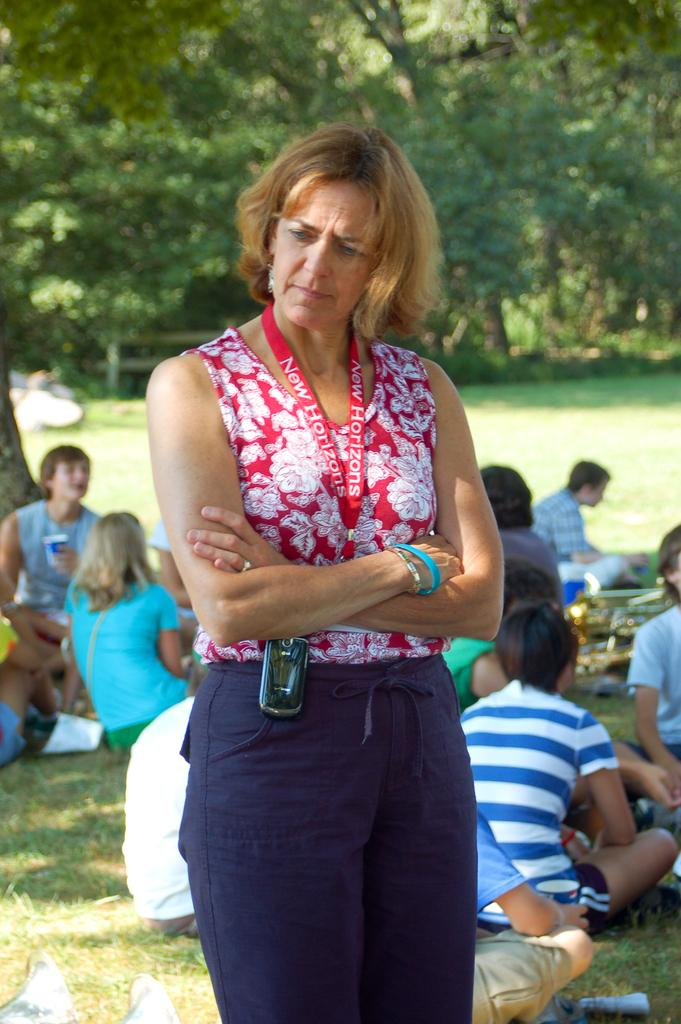What is the main subject of the image? There is a woman standing in the image. What are the other people in the image doing? There is a group of people sitting on the grass in the image. What can be seen in the background of the image? There are trees in the background of the image. What type of rod can be seen in the hands of the woman in the image? There is no rod present in the image; the woman is not holding anything. How many spiders are crawling on the woman in the image? There are no spiders present in the image; the woman is not interacting with any spiders. 